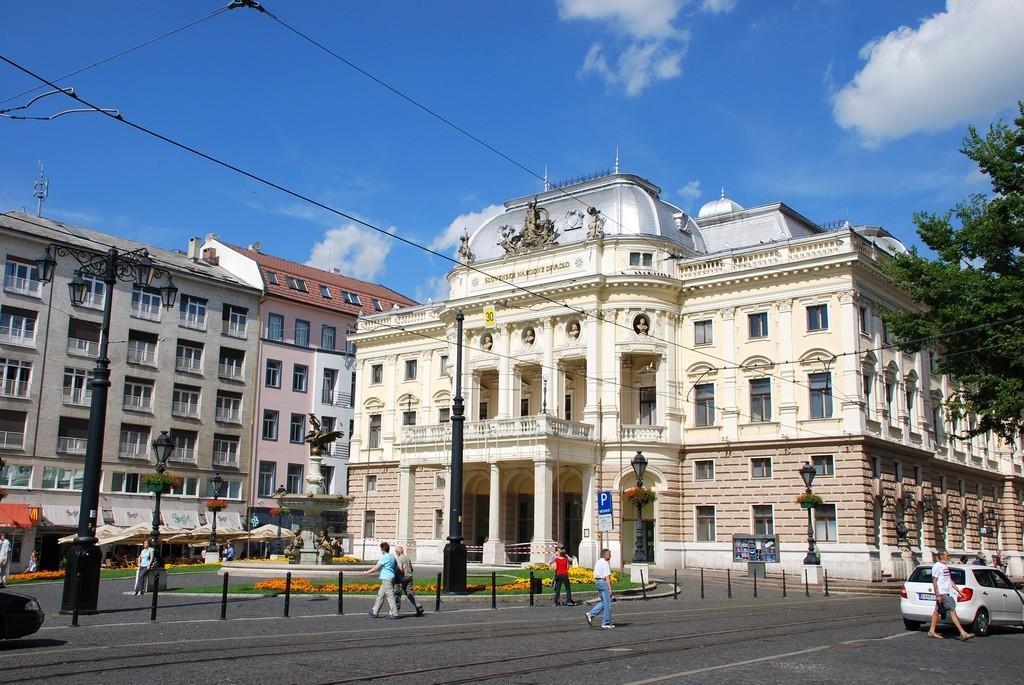Can you describe this image briefly? In the image we can see there are people walking on the road and there is a car parked on the road. Behind there are buildings and there is a tree. There are street light poles and there are wires on the top. There is a cloudy sky. 